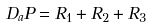<formula> <loc_0><loc_0><loc_500><loc_500>D _ { a } P = R _ { 1 } + R _ { 2 } + R _ { 3 }</formula> 